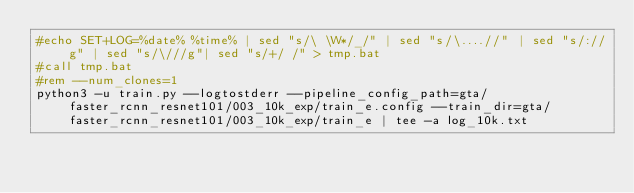<code> <loc_0><loc_0><loc_500><loc_500><_Bash_>#echo SET+LOG=%date% %time% | sed "s/\ \W*/_/" | sed "s/\....//" | sed "s/://g" | sed "s/\///g"| sed "s/+/ /" > tmp.bat
#call tmp.bat
#rem --num_clones=1
python3 -u train.py --logtostderr --pipeline_config_path=gta/faster_rcnn_resnet101/003_10k_exp/train_e.config --train_dir=gta/faster_rcnn_resnet101/003_10k_exp/train_e | tee -a log_10k.txt
</code> 